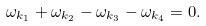Convert formula to latex. <formula><loc_0><loc_0><loc_500><loc_500>\omega _ { k _ { 1 } } + \omega _ { k _ { 2 } } - \omega _ { k _ { 3 } } - \omega _ { k _ { 4 } } = 0 .</formula> 